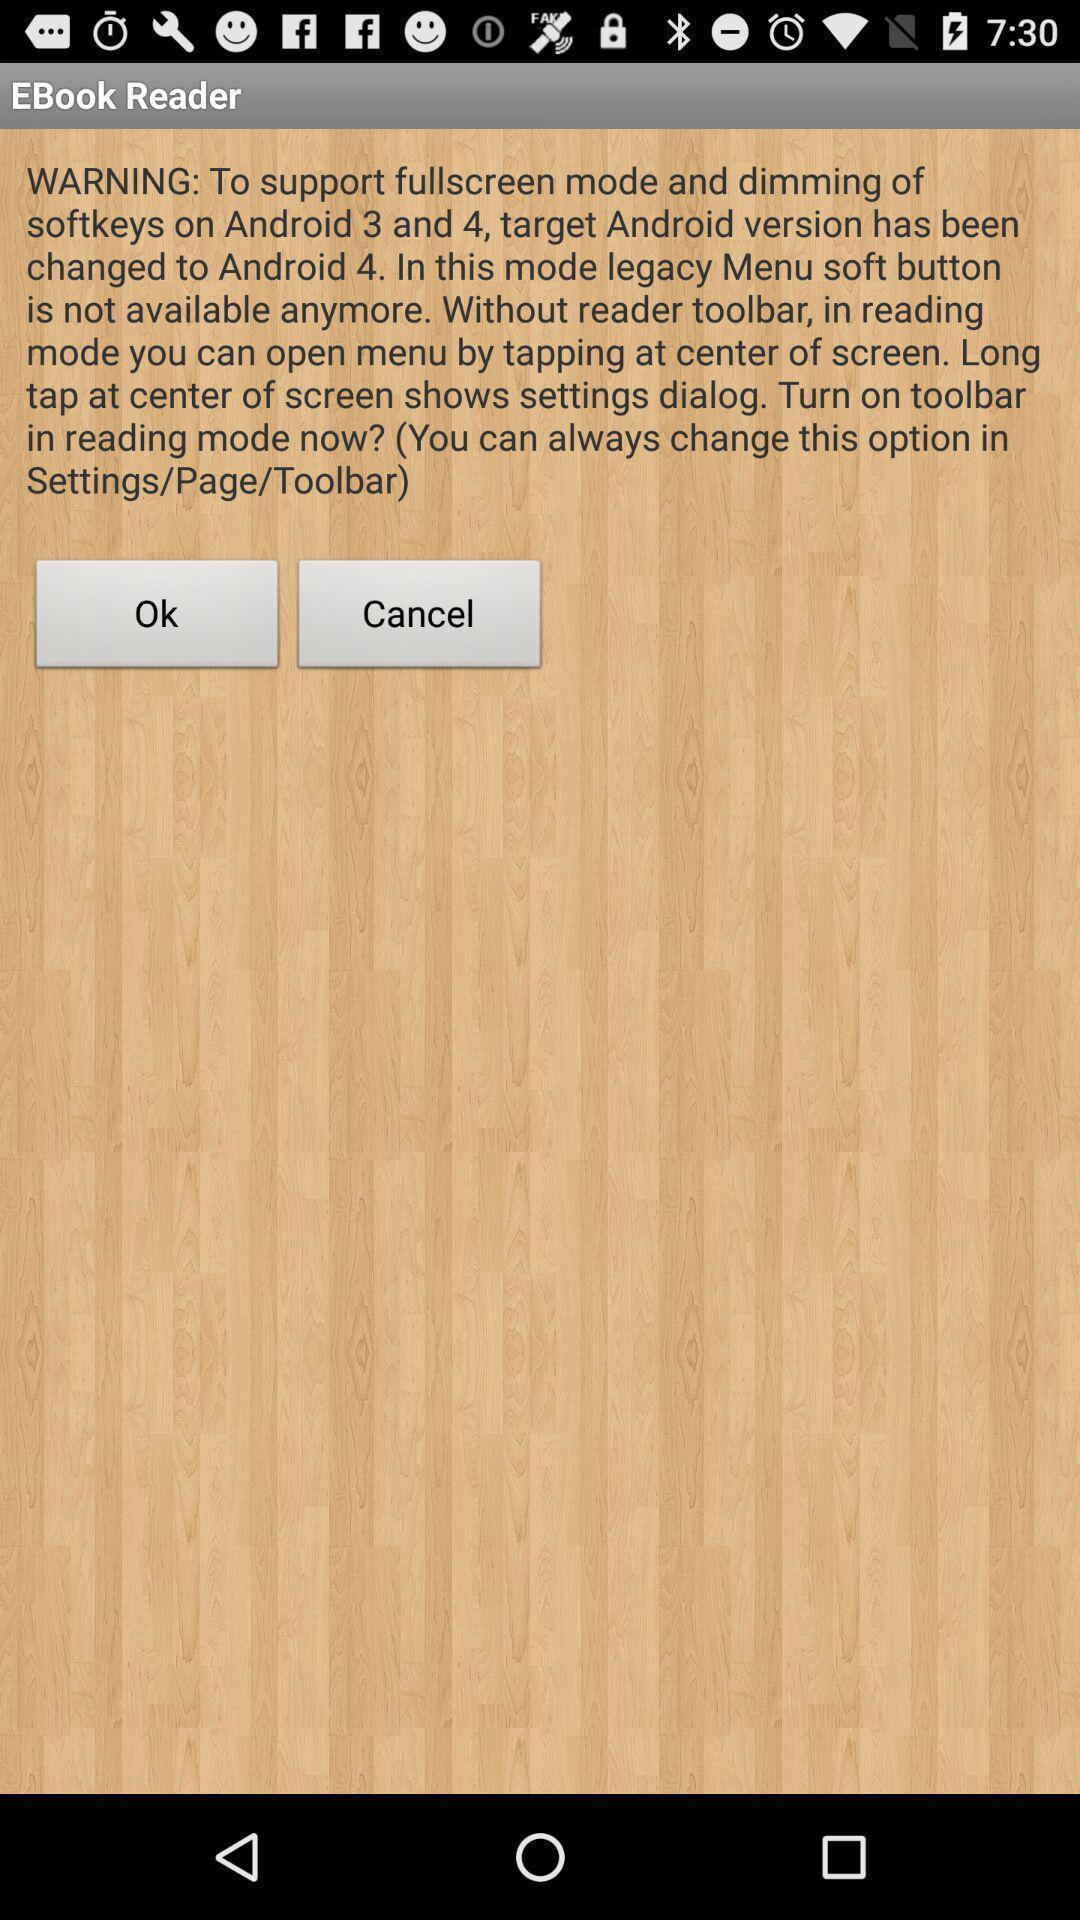What is the overall content of this screenshot? Warning app of a reading app. 